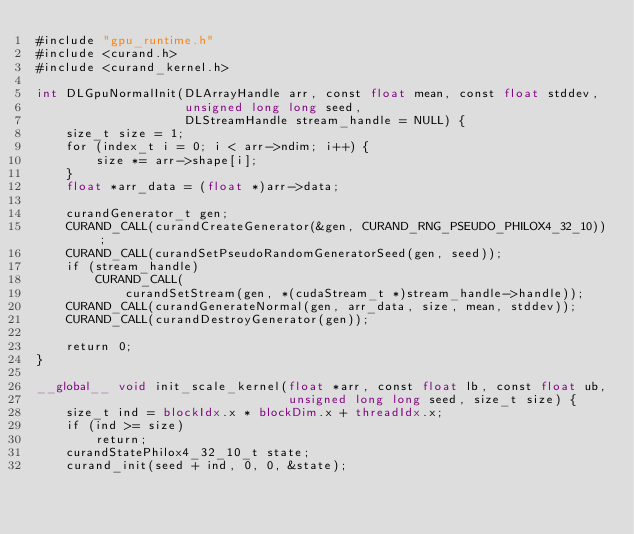Convert code to text. <code><loc_0><loc_0><loc_500><loc_500><_Cuda_>#include "gpu_runtime.h"
#include <curand.h>
#include <curand_kernel.h>

int DLGpuNormalInit(DLArrayHandle arr, const float mean, const float stddev,
                    unsigned long long seed,
                    DLStreamHandle stream_handle = NULL) {
    size_t size = 1;
    for (index_t i = 0; i < arr->ndim; i++) {
        size *= arr->shape[i];
    }
    float *arr_data = (float *)arr->data;

    curandGenerator_t gen;
    CURAND_CALL(curandCreateGenerator(&gen, CURAND_RNG_PSEUDO_PHILOX4_32_10));
    CURAND_CALL(curandSetPseudoRandomGeneratorSeed(gen, seed));
    if (stream_handle)
        CURAND_CALL(
            curandSetStream(gen, *(cudaStream_t *)stream_handle->handle));
    CURAND_CALL(curandGenerateNormal(gen, arr_data, size, mean, stddev));
    CURAND_CALL(curandDestroyGenerator(gen));

    return 0;
}

__global__ void init_scale_kernel(float *arr, const float lb, const float ub,
                                  unsigned long long seed, size_t size) {
    size_t ind = blockIdx.x * blockDim.x + threadIdx.x;
    if (ind >= size)
        return;
    curandStatePhilox4_32_10_t state;
    curand_init(seed + ind, 0, 0, &state);</code> 